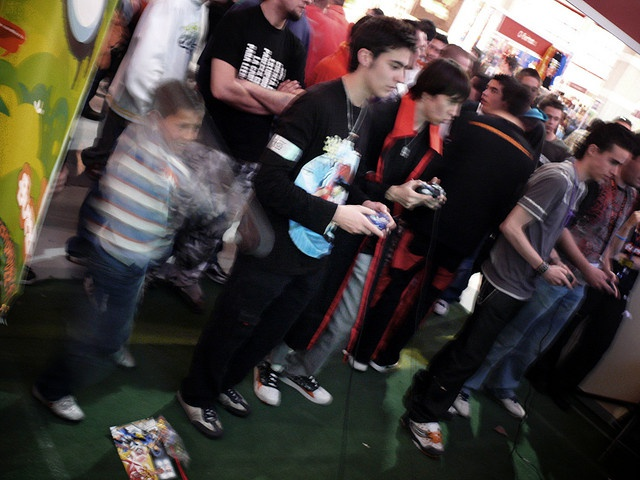Describe the objects in this image and their specific colors. I can see people in black, lightgray, darkgray, and gray tones, people in black, darkgray, and gray tones, people in black, maroon, gray, and brown tones, people in black, gray, darkgray, and brown tones, and people in black, gray, maroon, and darkgray tones in this image. 